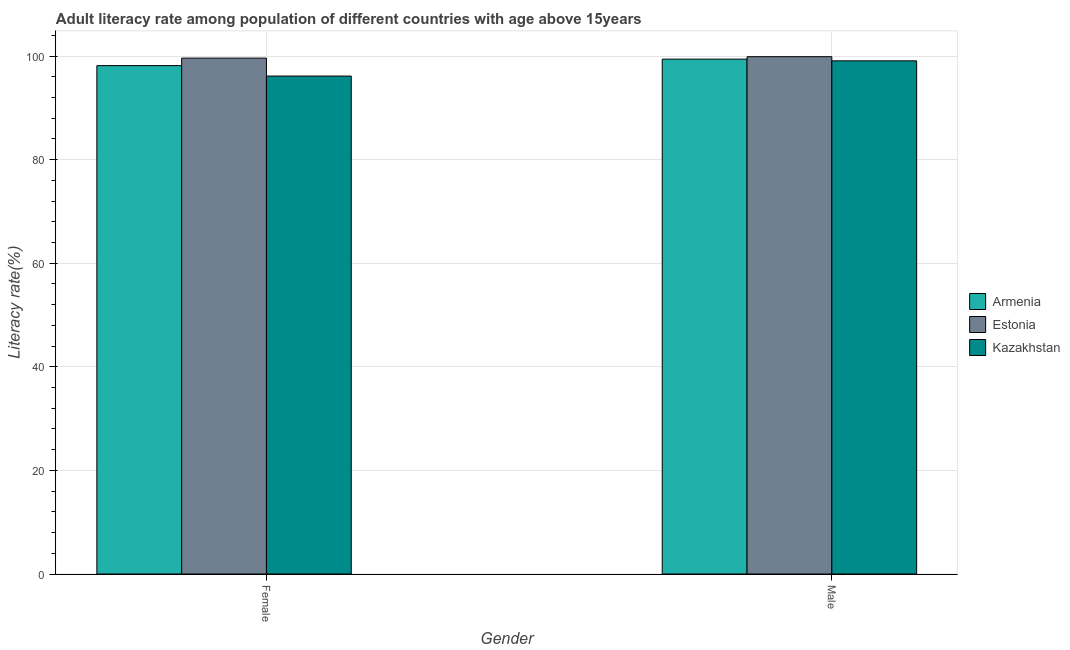How many different coloured bars are there?
Your answer should be very brief. 3. What is the male adult literacy rate in Armenia?
Your answer should be very brief. 99.4. Across all countries, what is the maximum female adult literacy rate?
Offer a very short reply. 99.6. Across all countries, what is the minimum female adult literacy rate?
Your answer should be compact. 96.14. In which country was the female adult literacy rate maximum?
Keep it short and to the point. Estonia. In which country was the male adult literacy rate minimum?
Provide a succinct answer. Kazakhstan. What is the total male adult literacy rate in the graph?
Give a very brief answer. 298.35. What is the difference between the male adult literacy rate in Kazakhstan and that in Estonia?
Your answer should be compact. -0.8. What is the difference between the male adult literacy rate in Armenia and the female adult literacy rate in Kazakhstan?
Ensure brevity in your answer.  3.27. What is the average female adult literacy rate per country?
Offer a terse response. 97.96. What is the difference between the female adult literacy rate and male adult literacy rate in Kazakhstan?
Provide a succinct answer. -2.93. What is the ratio of the male adult literacy rate in Kazakhstan to that in Estonia?
Give a very brief answer. 0.99. Is the female adult literacy rate in Armenia less than that in Estonia?
Give a very brief answer. Yes. In how many countries, is the female adult literacy rate greater than the average female adult literacy rate taken over all countries?
Give a very brief answer. 2. What does the 1st bar from the left in Female represents?
Your answer should be very brief. Armenia. What does the 1st bar from the right in Female represents?
Your answer should be very brief. Kazakhstan. How many bars are there?
Your answer should be very brief. 6. Are all the bars in the graph horizontal?
Offer a terse response. No. What is the difference between two consecutive major ticks on the Y-axis?
Make the answer very short. 20. Where does the legend appear in the graph?
Your response must be concise. Center right. How are the legend labels stacked?
Your response must be concise. Vertical. What is the title of the graph?
Your answer should be compact. Adult literacy rate among population of different countries with age above 15years. Does "Solomon Islands" appear as one of the legend labels in the graph?
Ensure brevity in your answer.  No. What is the label or title of the X-axis?
Provide a short and direct response. Gender. What is the label or title of the Y-axis?
Your answer should be compact. Literacy rate(%). What is the Literacy rate(%) of Armenia in Female?
Give a very brief answer. 98.15. What is the Literacy rate(%) of Estonia in Female?
Provide a short and direct response. 99.6. What is the Literacy rate(%) in Kazakhstan in Female?
Keep it short and to the point. 96.14. What is the Literacy rate(%) in Armenia in Male?
Your answer should be very brief. 99.4. What is the Literacy rate(%) of Estonia in Male?
Offer a very short reply. 99.88. What is the Literacy rate(%) in Kazakhstan in Male?
Your response must be concise. 99.07. Across all Gender, what is the maximum Literacy rate(%) in Armenia?
Keep it short and to the point. 99.4. Across all Gender, what is the maximum Literacy rate(%) of Estonia?
Ensure brevity in your answer.  99.88. Across all Gender, what is the maximum Literacy rate(%) of Kazakhstan?
Your answer should be very brief. 99.07. Across all Gender, what is the minimum Literacy rate(%) in Armenia?
Ensure brevity in your answer.  98.15. Across all Gender, what is the minimum Literacy rate(%) of Estonia?
Your response must be concise. 99.6. Across all Gender, what is the minimum Literacy rate(%) in Kazakhstan?
Ensure brevity in your answer.  96.14. What is the total Literacy rate(%) in Armenia in the graph?
Give a very brief answer. 197.55. What is the total Literacy rate(%) in Estonia in the graph?
Ensure brevity in your answer.  199.48. What is the total Literacy rate(%) of Kazakhstan in the graph?
Ensure brevity in your answer.  195.21. What is the difference between the Literacy rate(%) of Armenia in Female and that in Male?
Make the answer very short. -1.25. What is the difference between the Literacy rate(%) of Estonia in Female and that in Male?
Offer a very short reply. -0.27. What is the difference between the Literacy rate(%) of Kazakhstan in Female and that in Male?
Give a very brief answer. -2.93. What is the difference between the Literacy rate(%) of Armenia in Female and the Literacy rate(%) of Estonia in Male?
Offer a very short reply. -1.73. What is the difference between the Literacy rate(%) in Armenia in Female and the Literacy rate(%) in Kazakhstan in Male?
Ensure brevity in your answer.  -0.92. What is the difference between the Literacy rate(%) in Estonia in Female and the Literacy rate(%) in Kazakhstan in Male?
Ensure brevity in your answer.  0.53. What is the average Literacy rate(%) in Armenia per Gender?
Your response must be concise. 98.78. What is the average Literacy rate(%) of Estonia per Gender?
Provide a succinct answer. 99.74. What is the average Literacy rate(%) of Kazakhstan per Gender?
Make the answer very short. 97.61. What is the difference between the Literacy rate(%) of Armenia and Literacy rate(%) of Estonia in Female?
Offer a very short reply. -1.45. What is the difference between the Literacy rate(%) in Armenia and Literacy rate(%) in Kazakhstan in Female?
Make the answer very short. 2.01. What is the difference between the Literacy rate(%) of Estonia and Literacy rate(%) of Kazakhstan in Female?
Provide a short and direct response. 3.46. What is the difference between the Literacy rate(%) in Armenia and Literacy rate(%) in Estonia in Male?
Provide a short and direct response. -0.47. What is the difference between the Literacy rate(%) in Armenia and Literacy rate(%) in Kazakhstan in Male?
Your answer should be very brief. 0.33. What is the difference between the Literacy rate(%) of Estonia and Literacy rate(%) of Kazakhstan in Male?
Your response must be concise. 0.8. What is the ratio of the Literacy rate(%) in Armenia in Female to that in Male?
Provide a short and direct response. 0.99. What is the ratio of the Literacy rate(%) in Estonia in Female to that in Male?
Your answer should be very brief. 1. What is the ratio of the Literacy rate(%) in Kazakhstan in Female to that in Male?
Your answer should be very brief. 0.97. What is the difference between the highest and the second highest Literacy rate(%) in Armenia?
Keep it short and to the point. 1.25. What is the difference between the highest and the second highest Literacy rate(%) in Estonia?
Provide a short and direct response. 0.27. What is the difference between the highest and the second highest Literacy rate(%) in Kazakhstan?
Give a very brief answer. 2.93. What is the difference between the highest and the lowest Literacy rate(%) of Armenia?
Keep it short and to the point. 1.25. What is the difference between the highest and the lowest Literacy rate(%) in Estonia?
Offer a very short reply. 0.27. What is the difference between the highest and the lowest Literacy rate(%) of Kazakhstan?
Make the answer very short. 2.93. 